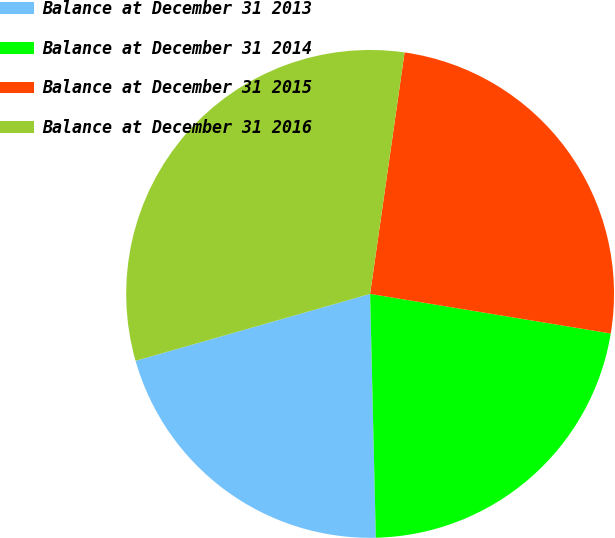Convert chart. <chart><loc_0><loc_0><loc_500><loc_500><pie_chart><fcel>Balance at December 31 2013<fcel>Balance at December 31 2014<fcel>Balance at December 31 2015<fcel>Balance at December 31 2016<nl><fcel>20.95%<fcel>22.03%<fcel>25.34%<fcel>31.68%<nl></chart> 